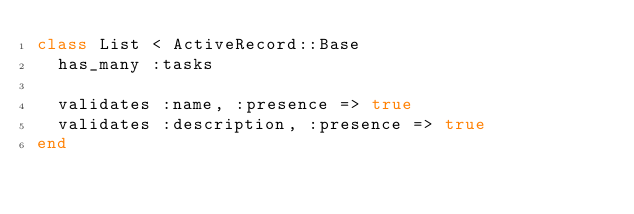<code> <loc_0><loc_0><loc_500><loc_500><_Ruby_>class List < ActiveRecord::Base
  has_many :tasks

  validates :name, :presence => true
  validates :description, :presence => true
end
</code> 